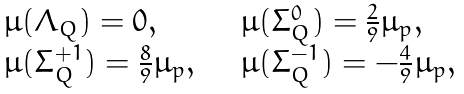Convert formula to latex. <formula><loc_0><loc_0><loc_500><loc_500>\begin{array} { l l } \mu ( \Lambda _ { Q } ) = 0 , & \mu ( \Sigma _ { Q } ^ { 0 } ) = \frac { 2 } { 9 } \mu _ { p } , \\ \mu ( \Sigma _ { Q } ^ { + 1 } ) = \frac { 8 } { 9 } \mu _ { p } , \quad & \mu ( \Sigma _ { Q } ^ { - 1 } ) = - \frac { 4 } { 9 } \mu _ { p } , \end{array}</formula> 